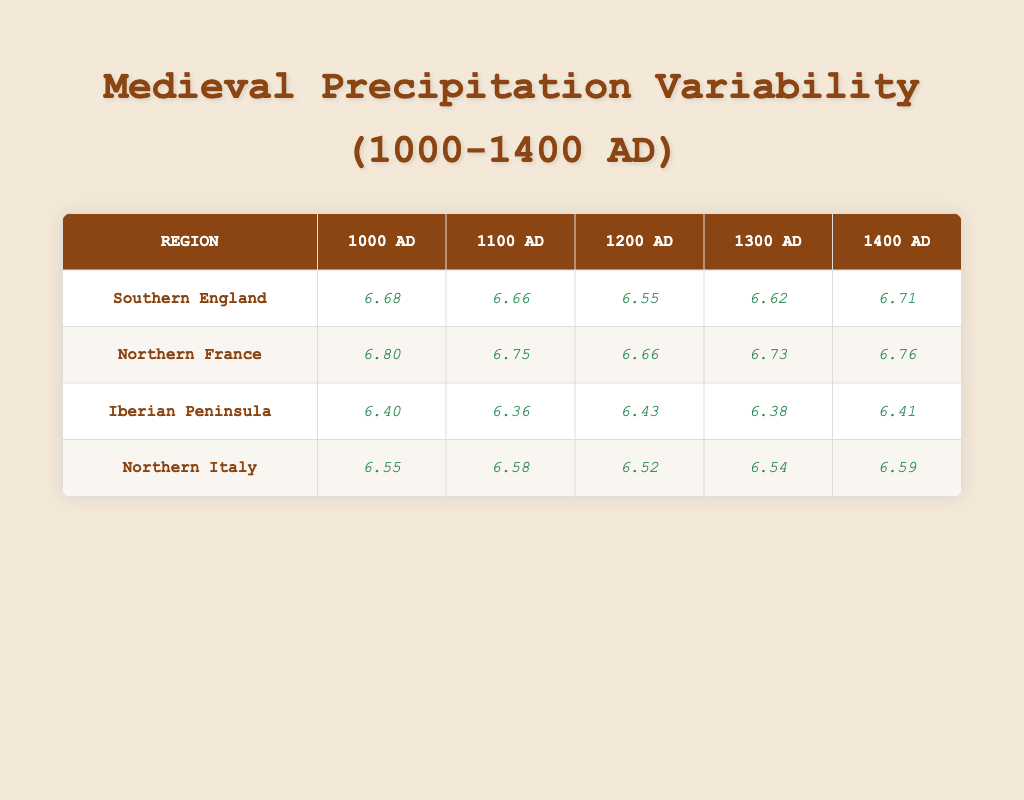What was the lowest annual precipitation recorded in Southern England during the years provided? Scanning the table, the precipitation values for Southern England are 800, 780, 700, 750, and 820 mm. The lowest value among these is 700 mm, recorded in 1200 AD.
Answer: 700 mm What is the logarithmic value of precipitation for Northern France in 1400 AD? By looking at the table, the precipitation for Northern France in 1400 AD is 860 mm. The corresponding logarithmic value listed is 6.76.
Answer: 6.76 Did the Iberian Peninsula experience an increase in annual precipitation from 1000 AD to 1400 AD? Examining the values for the Iberian Peninsula: the precipitation amounts are 600 mm in 1000 AD and 610 mm in 1400 AD. Since 610 mm is greater than 600 mm, this indicates an increase.
Answer: Yes What is the average logarithmic value of precipitation for Northern Italy between 1000 AD and 1400 AD? The logarithmic values for Northern Italy are 6.55, 6.58, 6.52, 6.54, and 6.59. Adding these gives 32.78, and dividing by 5 (the number of years) results in an average of 6.556.
Answer: 6.56 Which region had the highest annual precipitation recorded in 1300 AD? The precipitation values for 1300 AD are Southern England (750 mm), Northern France (840 mm), Iberian Peninsula (590 mm), and Northern Italy (690 mm). The highest among these is 840 mm for Northern France.
Answer: Northern France What was the difference in logarithmic values between 1000 AD and 1400 AD for Southern England? The logarithmic values for Southern England in 1000 AD and 1400 AD are 6.68 and 6.71, respectively. The difference is calculated as 6.71 - 6.68 = 0.03.
Answer: 0.03 Was the precipitation in 1200 AD for Northern France lower than that of the Iberian Peninsula? The precipitation for Northern France in 1200 AD is 780 mm, while for the Iberian Peninsula, it is 620 mm. Since 780 mm is greater than 620 mm, the statement is false.
Answer: No What was the highest logarithmic value recorded in any region for 1400 AD? The logarithmic values for 1400 AD are 6.71 (Southern England), 6.76 (Northern France), 6.41 (Iberian Peninsula), and 6.59 (Northern Italy). The highest is 6.76 from Northern France.
Answer: 6.76 